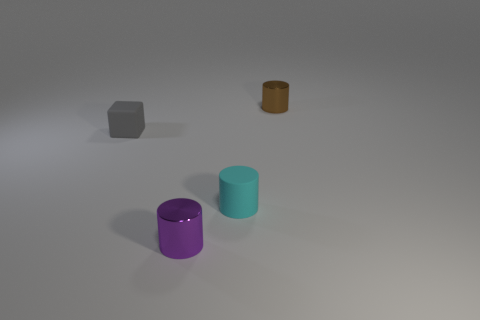Subtract all shiny cylinders. How many cylinders are left? 1 Subtract all purple cylinders. How many cylinders are left? 2 Subtract 1 cylinders. How many cylinders are left? 2 Add 1 purple things. How many purple things are left? 2 Add 4 tiny brown metal balls. How many tiny brown metal balls exist? 4 Add 4 purple cylinders. How many objects exist? 8 Subtract 0 gray cylinders. How many objects are left? 4 Subtract all cylinders. How many objects are left? 1 Subtract all brown cubes. Subtract all red cylinders. How many cubes are left? 1 Subtract all yellow spheres. How many blue blocks are left? 0 